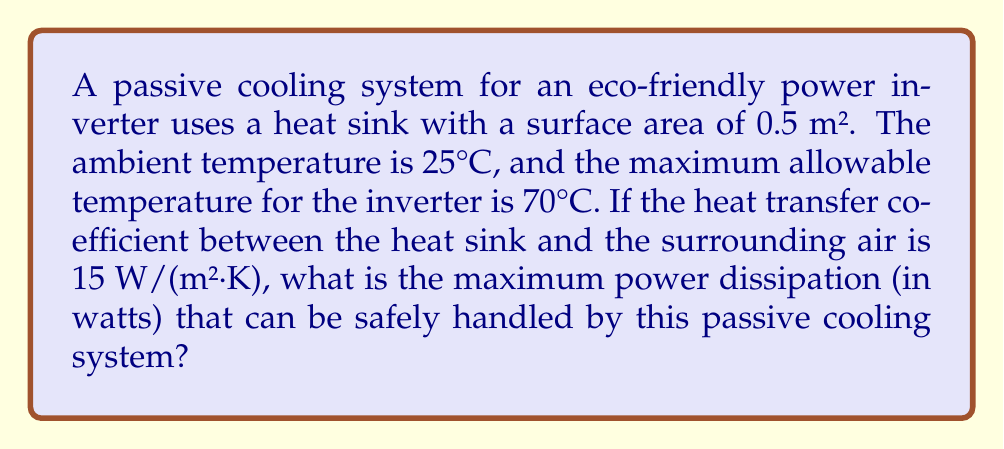Solve this math problem. To solve this problem, we'll use Newton's Law of Cooling:

$$ Q = hA(T_s - T_a) $$

Where:
$Q$ = heat transfer rate (power dissipation) in watts
$h$ = heat transfer coefficient in W/(m²·K)
$A$ = surface area of the heat sink in m²
$T_s$ = surface temperature of the heat sink (equal to the maximum allowable temperature of the inverter)
$T_a$ = ambient temperature

Given:
$h = 15$ W/(m²·K)
$A = 0.5$ m²
$T_s = 70°C = 343.15$ K
$T_a = 25°C = 298.15$ K

Step 1: Substitute the given values into Newton's Law of Cooling equation:

$$ Q = 15 \cdot 0.5 \cdot (343.15 - 298.15) $$

Step 2: Simplify and calculate:

$$ Q = 15 \cdot 0.5 \cdot 45 $$
$$ Q = 7.5 \cdot 45 $$
$$ Q = 337.5 \text{ W} $$

Therefore, the maximum power dissipation that can be safely handled by this passive cooling system is 337.5 watts.
Answer: 337.5 W 